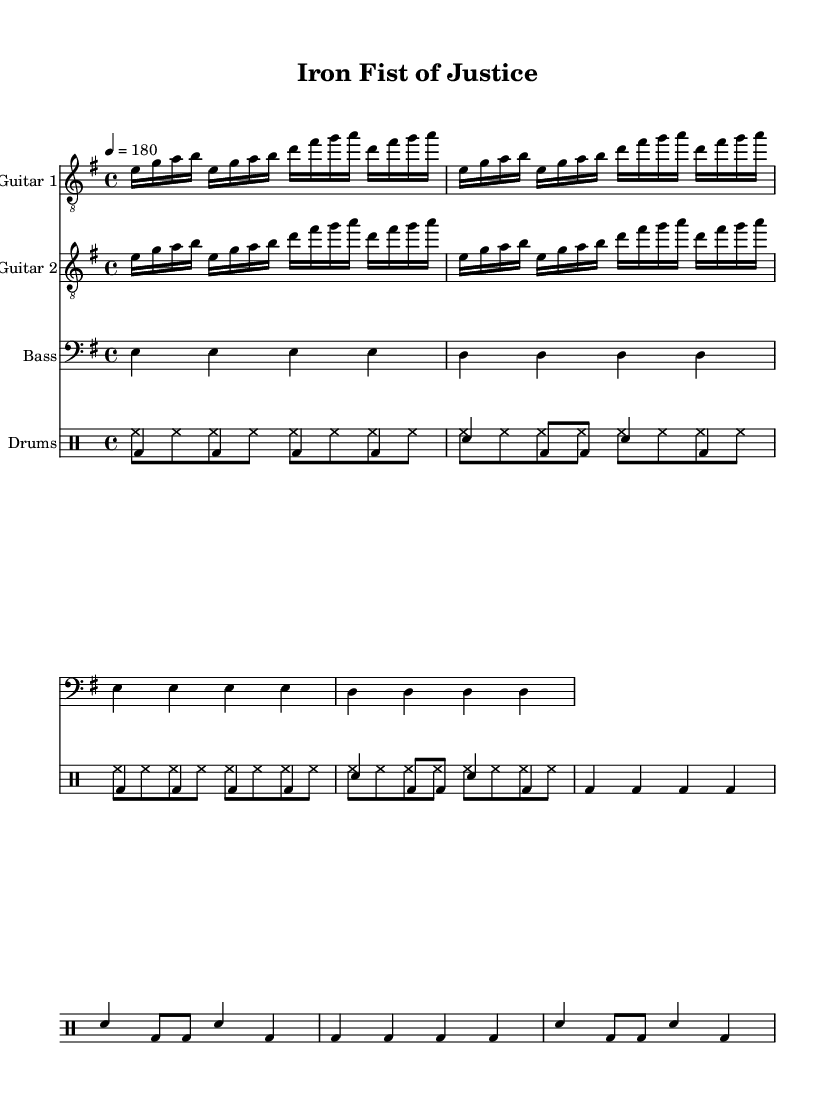What is the key signature of this music? The key signature is E minor, which has one sharp (F#) and is indicated at the beginning of the staff.
Answer: E minor What is the time signature of this music? The time signature is 4/4, represented on the left side of the staff. It indicates that there are four beats per measure.
Answer: 4/4 What is the tempo marking for this piece? The tempo marking indicates a speed of 180 beats per minute, shown as "4 = 180" under the header.
Answer: 180 How many measures are repeated in the guitar sections? Both guitar parts feature a repeat of two measures, indicated by the "repeat unfold 2" command.
Answer: 2 What type of music is this? This music is categorized as aggressive thrash metal, characterized by fast tempos and intense rhythms; the overall theme is about law enforcement and order.
Answer: Aggressive thrash metal What instrument plays the bass line? The bass line is played by a bass guitar, as indicated by the staff designation.
Answer: Bass How are the drums structured in this piece? The drum part includes pitched (bass and snare) and unpitched (hi-hat) voices, important for the heavy rhythmic foundation of thrash metal.
Answer: Pitched and unpitched 